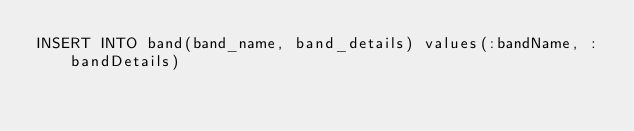Convert code to text. <code><loc_0><loc_0><loc_500><loc_500><_SQL_>INSERT INTO band(band_name, band_details) values(:bandName, :bandDetails)</code> 